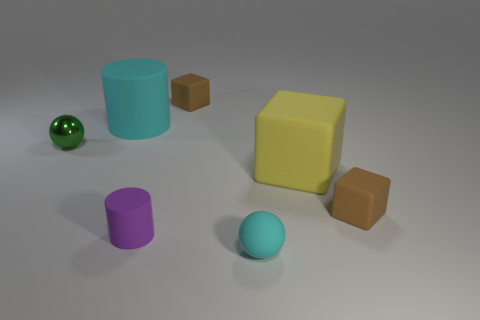Add 1 shiny things. How many objects exist? 8 Subtract all spheres. How many objects are left? 5 Add 1 yellow things. How many yellow things exist? 2 Subtract 1 cyan balls. How many objects are left? 6 Subtract all small shiny cylinders. Subtract all yellow cubes. How many objects are left? 6 Add 7 large yellow rubber things. How many large yellow rubber things are left? 8 